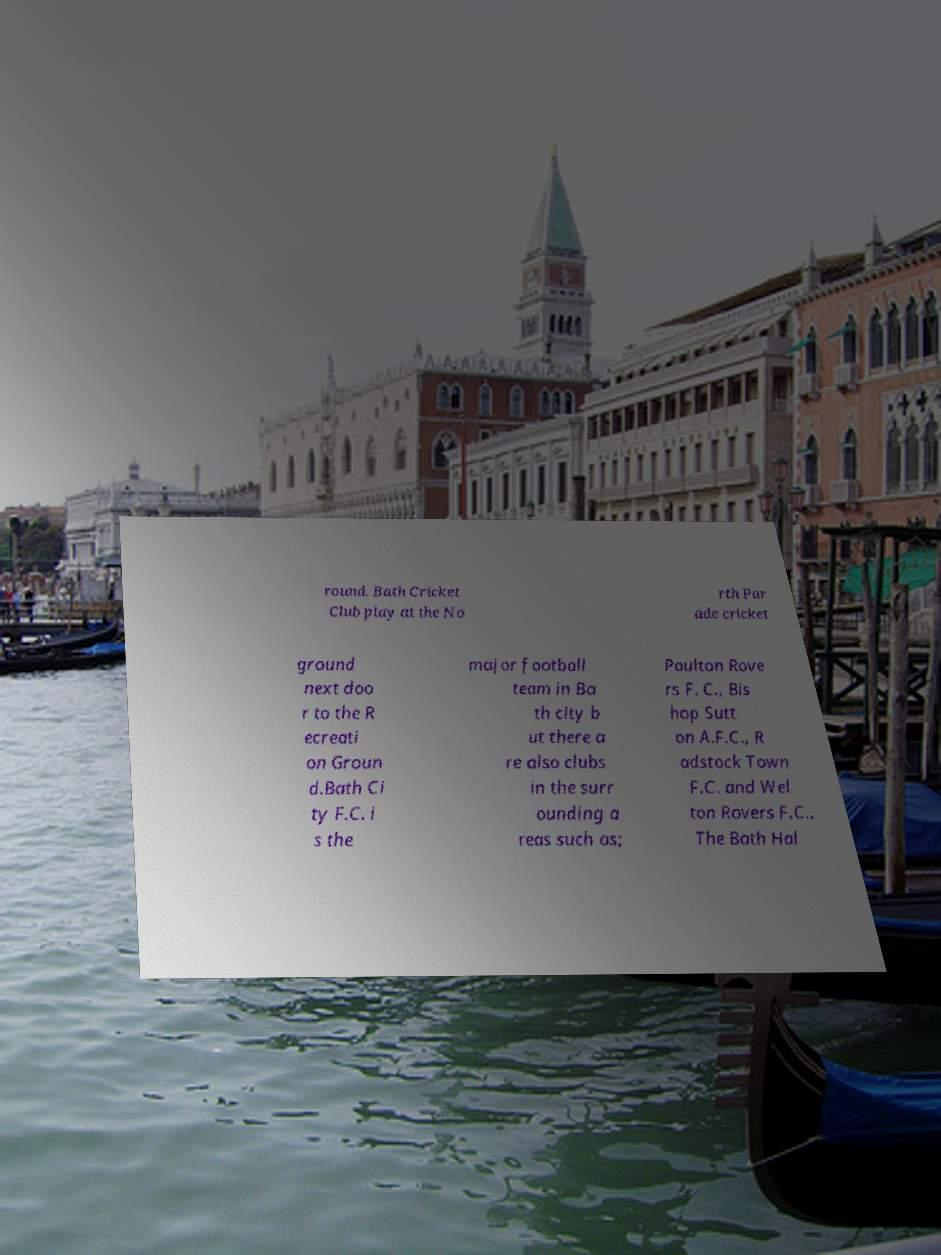For documentation purposes, I need the text within this image transcribed. Could you provide that? round. Bath Cricket Club play at the No rth Par ade cricket ground next doo r to the R ecreati on Groun d.Bath Ci ty F.C. i s the major football team in Ba th city b ut there a re also clubs in the surr ounding a reas such as; Paulton Rove rs F. C., Bis hop Sutt on A.F.C., R adstock Town F.C. and Wel ton Rovers F.C.. The Bath Hal 